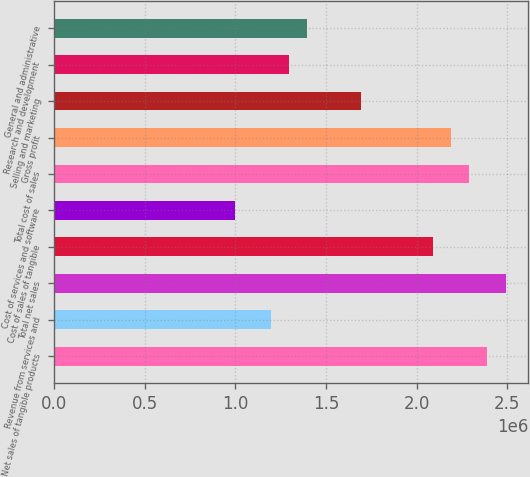Convert chart. <chart><loc_0><loc_0><loc_500><loc_500><bar_chart><fcel>Net sales of tangible products<fcel>Revenue from services and<fcel>Total net sales<fcel>Cost of sales of tangible<fcel>Cost of services and software<fcel>Total cost of sales<fcel>Gross profit<fcel>Selling and marketing<fcel>Research and development<fcel>General and administrative<nl><fcel>2.3908e+06<fcel>1.1954e+06<fcel>2.49042e+06<fcel>2.09195e+06<fcel>996168<fcel>2.29119e+06<fcel>2.19157e+06<fcel>1.69349e+06<fcel>1.29502e+06<fcel>1.39463e+06<nl></chart> 